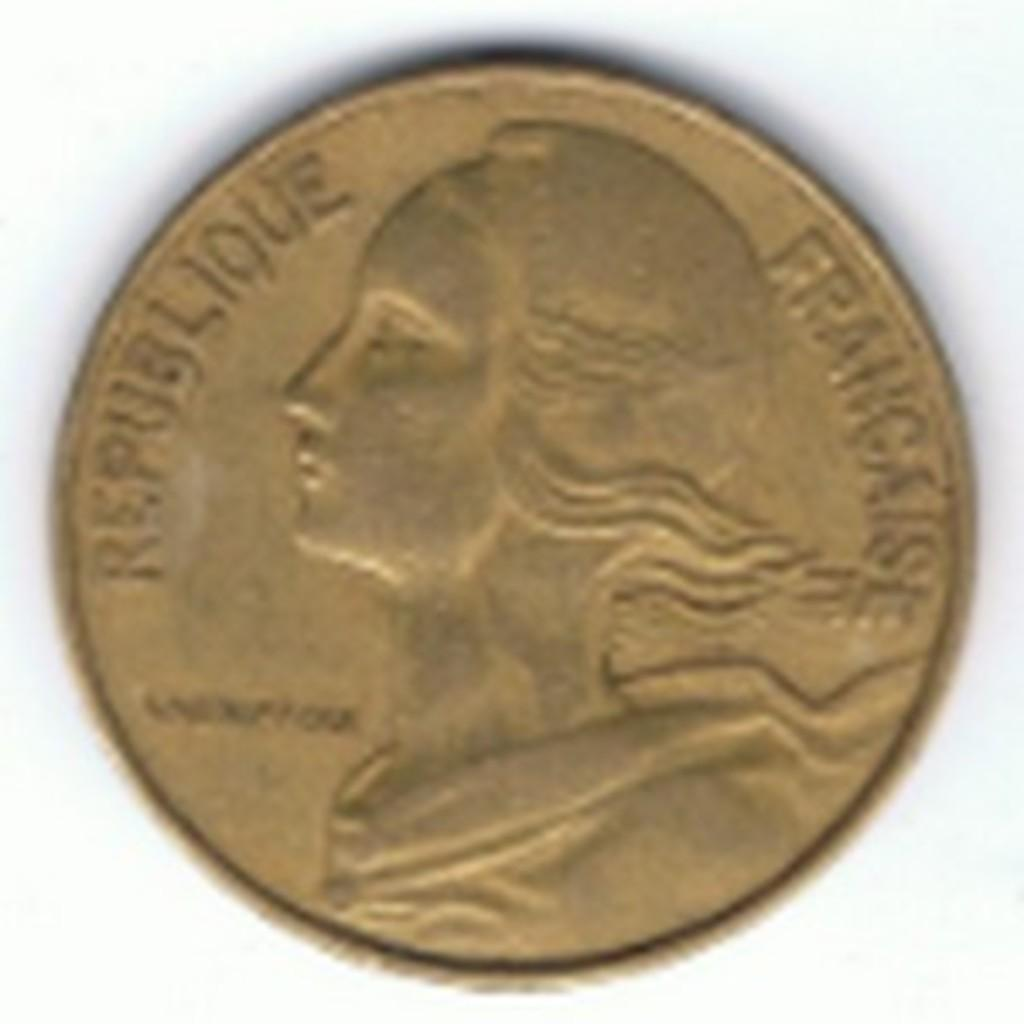<image>
Write a terse but informative summary of the picture. An old coin on a white background with the words Republique Francaise on it 